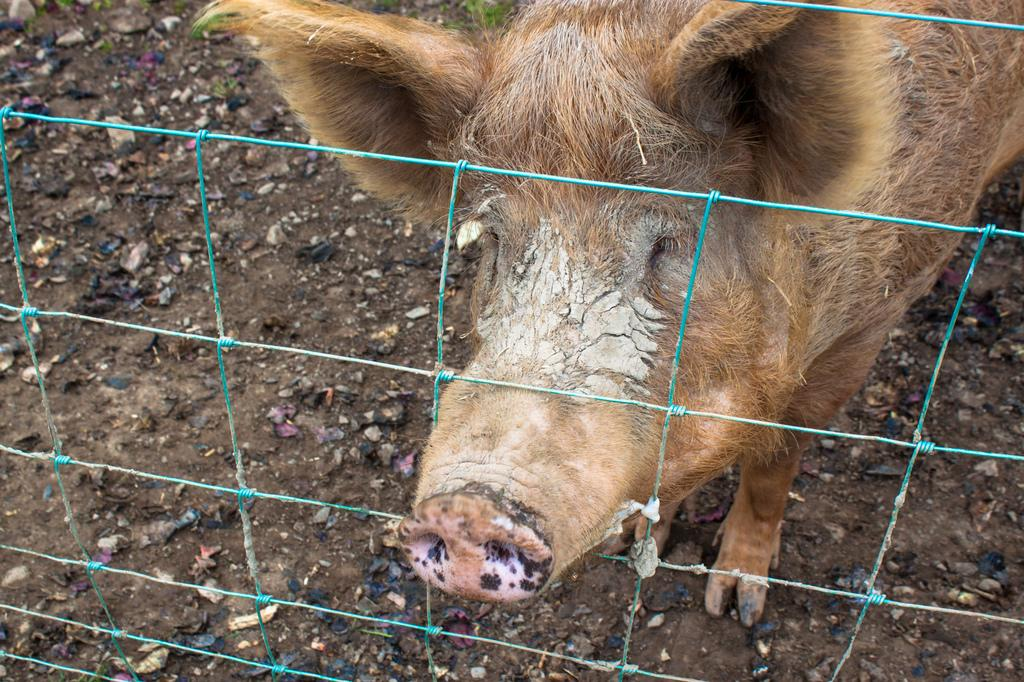What animal is in the center of the image? There is a pig in the center of the image. What can be seen surrounding the pig? There is a fence in the image. What type of terrain is visible at the bottom of the image? There is sand and small stones at the bottom of the image. What hobbies does the pig have, as depicted in the image? The image does not provide information about the pig's hobbies. 